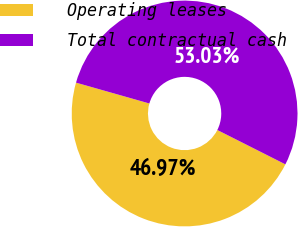Convert chart to OTSL. <chart><loc_0><loc_0><loc_500><loc_500><pie_chart><fcel>Operating leases<fcel>Total contractual cash<nl><fcel>46.97%<fcel>53.03%<nl></chart> 